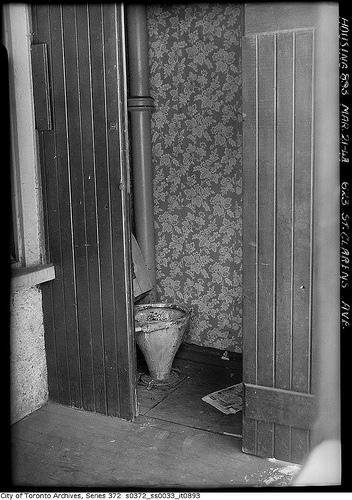Identify the type of room shown in the image. The image shows a bathroom. State the type of object found on the ground and provide a brief description. A discarded and aged newspaper from simpler times is found on the ground with a page of it lying around. List and briefly describe the materials mentioned in the description of the various surfaces in the image. Metal - plumbing pipe, pole running along the wall, conical toilet. Describe the condition of the toilet in the image. The toilet is an old, disgusting, dirty, conical shaped and made of ceramic with dirt and feces inside. The back of the toilet is severely broken. How many wooden planks are mentioned in the image description, and where are they mainly located? There are four wooden planks mentioned in the image description, primarily located around the floor and the doorway. What is an unusual feature of the floor and what is its purpose? The unusual feature of the floor is the literal hole in the ground, which is used as a restroom. What objects or elements are related to the window in the image? The objects and elements related to the window in the image are the white wooden surface of the window sill, the ledge on the wall, the corner of the window, and the block window sill. What is the primary pattern on the wall and describe its style. The primary pattern on the wall is a floral design, giving an ivy and vine wallpaper style. What sentiment could be associated with the style and objects in the image? A feeling of neglect, dirtiness, and decay could be associated with the style and objects in the image. 